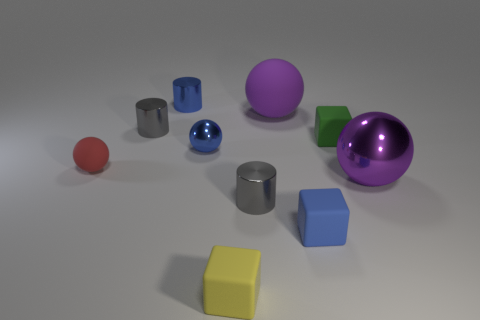Subtract all tiny blue spheres. How many spheres are left? 3 Subtract all cylinders. How many objects are left? 7 Subtract 3 cubes. How many cubes are left? 0 Add 1 large brown matte blocks. How many large brown matte blocks exist? 1 Subtract all blue cubes. How many cubes are left? 2 Subtract 2 gray cylinders. How many objects are left? 8 Subtract all blue balls. Subtract all purple cylinders. How many balls are left? 3 Subtract all red blocks. How many blue balls are left? 1 Subtract all gray matte cubes. Subtract all tiny gray shiny cylinders. How many objects are left? 8 Add 3 small red rubber balls. How many small red rubber balls are left? 4 